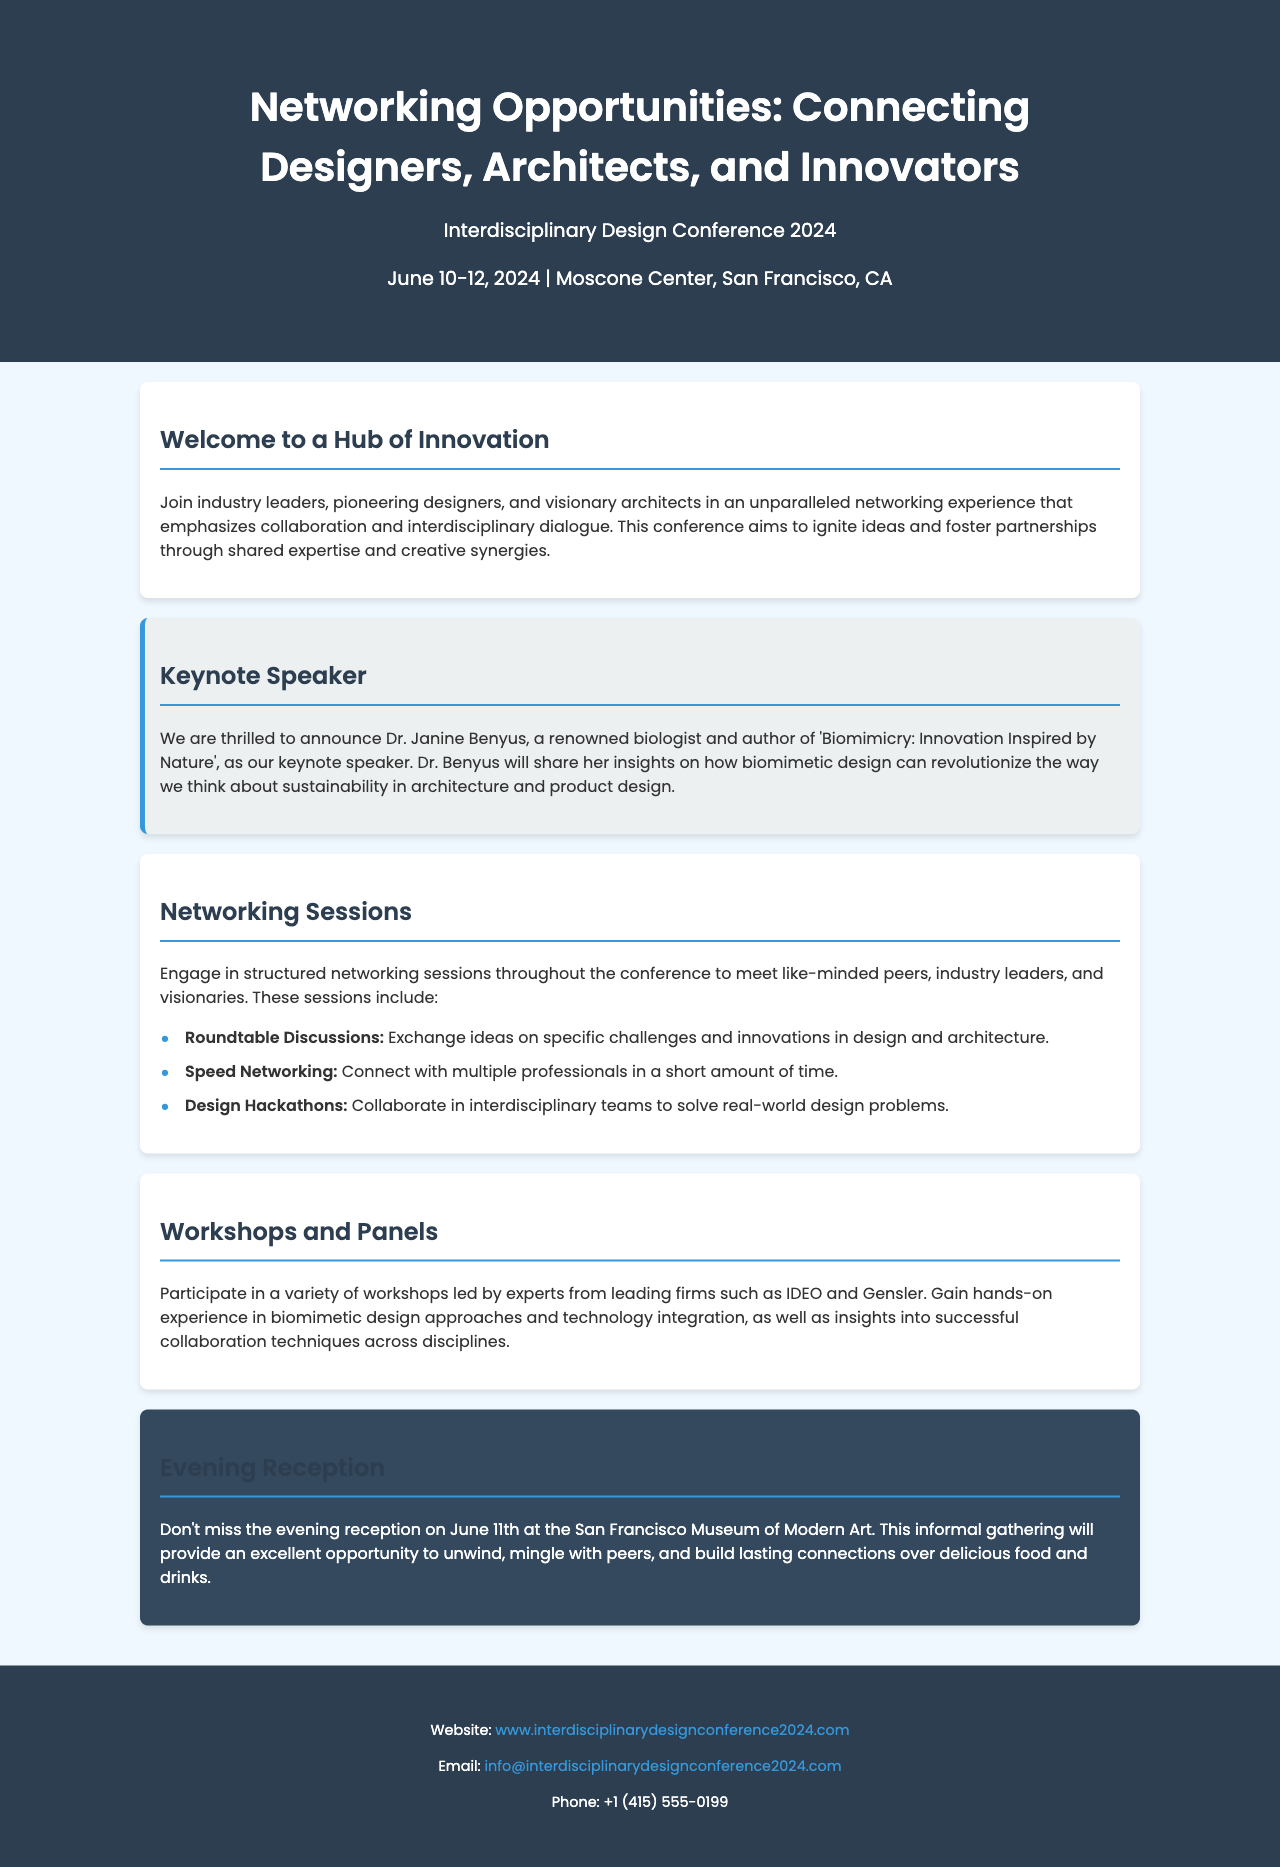What is the title of the conference? The title of the conference is mentioned at the beginning of the document.
Answer: Networking Opportunities: Connecting Designers, Architects, and Innovators Who is the keynote speaker? The keynote speaker is outlined in the Keynote Speaker section of the document.
Answer: Dr. Janine Benyus What dates will the conference take place? The dates are provided in the conference details section of the document.
Answer: June 10-12, 2024 Where will the evening reception be held? The location of the evening reception is stated in the Evening Reception section.
Answer: San Francisco Museum of Modern Art What type of sessions will be offered for networking? Different types of networking sessions are described in the Networking Sessions section.
Answer: Roundtable Discussions, Speed Networking, Design Hackathons What is Dr. Janine Benyus known for? The document mentions her recognition in the context of the keynote speech.
Answer: Biomimicry: Innovation Inspired by Nature Which firms will lead the workshops? The workshops and panels section mentions the firms providing workshops.
Answer: IDEO and Gensler What is the purpose of the conference? The introduction section describes the overall intent of the conference.
Answer: Ignite ideas and foster partnerships What will attendees gain from the workshops? The document specifies benefits of participating in workshops.
Answer: Hands-on experience in biomimetic design approaches and technology integration 